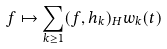<formula> <loc_0><loc_0><loc_500><loc_500>f \mapsto \sum _ { k \geq 1 } ( f , h _ { k } ) _ { H } w _ { k } ( t )</formula> 